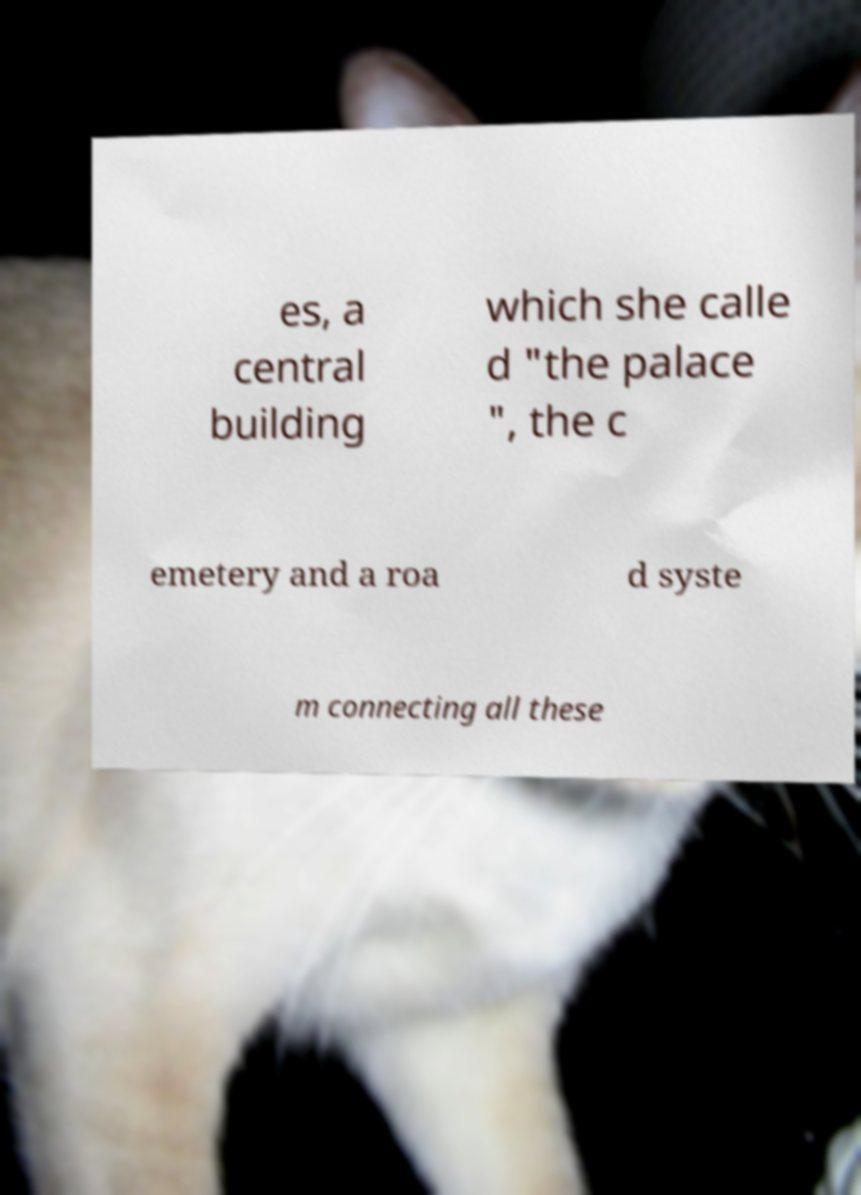I need the written content from this picture converted into text. Can you do that? es, a central building which she calle d "the palace ", the c emetery and a roa d syste m connecting all these 